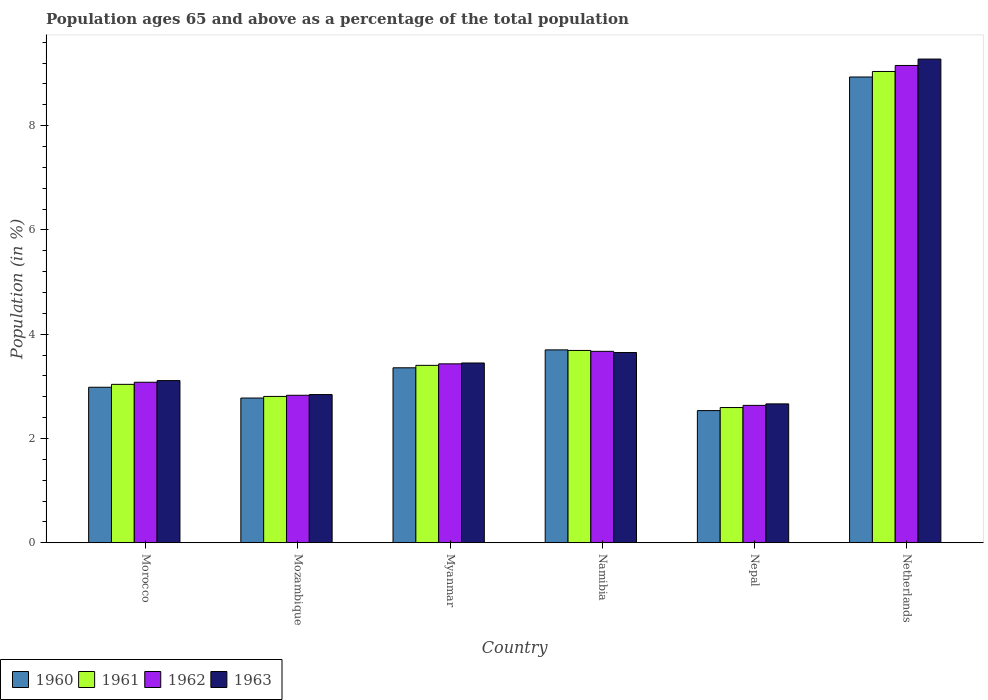How many groups of bars are there?
Give a very brief answer. 6. Are the number of bars on each tick of the X-axis equal?
Give a very brief answer. Yes. What is the label of the 3rd group of bars from the left?
Offer a very short reply. Myanmar. What is the percentage of the population ages 65 and above in 1960 in Nepal?
Offer a very short reply. 2.53. Across all countries, what is the maximum percentage of the population ages 65 and above in 1962?
Provide a short and direct response. 9.15. Across all countries, what is the minimum percentage of the population ages 65 and above in 1960?
Your answer should be very brief. 2.53. In which country was the percentage of the population ages 65 and above in 1963 minimum?
Keep it short and to the point. Nepal. What is the total percentage of the population ages 65 and above in 1960 in the graph?
Provide a short and direct response. 24.28. What is the difference between the percentage of the population ages 65 and above in 1961 in Nepal and that in Netherlands?
Your answer should be compact. -6.45. What is the difference between the percentage of the population ages 65 and above in 1960 in Namibia and the percentage of the population ages 65 and above in 1961 in Mozambique?
Offer a very short reply. 0.89. What is the average percentage of the population ages 65 and above in 1960 per country?
Offer a very short reply. 4.05. What is the difference between the percentage of the population ages 65 and above of/in 1962 and percentage of the population ages 65 and above of/in 1963 in Mozambique?
Provide a short and direct response. -0.01. What is the ratio of the percentage of the population ages 65 and above in 1961 in Morocco to that in Namibia?
Provide a succinct answer. 0.82. Is the percentage of the population ages 65 and above in 1961 in Morocco less than that in Namibia?
Provide a succinct answer. Yes. What is the difference between the highest and the second highest percentage of the population ages 65 and above in 1963?
Offer a very short reply. -5.83. What is the difference between the highest and the lowest percentage of the population ages 65 and above in 1960?
Your response must be concise. 6.4. In how many countries, is the percentage of the population ages 65 and above in 1960 greater than the average percentage of the population ages 65 and above in 1960 taken over all countries?
Ensure brevity in your answer.  1. Is it the case that in every country, the sum of the percentage of the population ages 65 and above in 1961 and percentage of the population ages 65 and above in 1963 is greater than the sum of percentage of the population ages 65 and above in 1962 and percentage of the population ages 65 and above in 1960?
Offer a terse response. No. What does the 1st bar from the left in Myanmar represents?
Provide a succinct answer. 1960. Is it the case that in every country, the sum of the percentage of the population ages 65 and above in 1960 and percentage of the population ages 65 and above in 1961 is greater than the percentage of the population ages 65 and above in 1963?
Ensure brevity in your answer.  Yes. How many countries are there in the graph?
Make the answer very short. 6. What is the difference between two consecutive major ticks on the Y-axis?
Your answer should be compact. 2. Does the graph contain any zero values?
Give a very brief answer. No. How are the legend labels stacked?
Ensure brevity in your answer.  Horizontal. What is the title of the graph?
Offer a very short reply. Population ages 65 and above as a percentage of the total population. Does "2005" appear as one of the legend labels in the graph?
Give a very brief answer. No. What is the label or title of the Y-axis?
Your answer should be compact. Population (in %). What is the Population (in %) in 1960 in Morocco?
Your response must be concise. 2.98. What is the Population (in %) of 1961 in Morocco?
Your response must be concise. 3.04. What is the Population (in %) of 1962 in Morocco?
Ensure brevity in your answer.  3.08. What is the Population (in %) of 1963 in Morocco?
Your answer should be very brief. 3.11. What is the Population (in %) in 1960 in Mozambique?
Offer a very short reply. 2.78. What is the Population (in %) in 1961 in Mozambique?
Provide a succinct answer. 2.81. What is the Population (in %) of 1962 in Mozambique?
Your answer should be very brief. 2.83. What is the Population (in %) of 1963 in Mozambique?
Keep it short and to the point. 2.84. What is the Population (in %) in 1960 in Myanmar?
Give a very brief answer. 3.36. What is the Population (in %) of 1961 in Myanmar?
Your answer should be compact. 3.4. What is the Population (in %) in 1962 in Myanmar?
Provide a short and direct response. 3.43. What is the Population (in %) of 1963 in Myanmar?
Make the answer very short. 3.45. What is the Population (in %) of 1960 in Namibia?
Provide a short and direct response. 3.7. What is the Population (in %) of 1961 in Namibia?
Offer a very short reply. 3.69. What is the Population (in %) of 1962 in Namibia?
Your response must be concise. 3.67. What is the Population (in %) of 1963 in Namibia?
Offer a very short reply. 3.65. What is the Population (in %) in 1960 in Nepal?
Give a very brief answer. 2.53. What is the Population (in %) of 1961 in Nepal?
Give a very brief answer. 2.59. What is the Population (in %) in 1962 in Nepal?
Your answer should be compact. 2.63. What is the Population (in %) of 1963 in Nepal?
Provide a succinct answer. 2.66. What is the Population (in %) of 1960 in Netherlands?
Your answer should be compact. 8.93. What is the Population (in %) in 1961 in Netherlands?
Provide a succinct answer. 9.04. What is the Population (in %) of 1962 in Netherlands?
Provide a succinct answer. 9.15. What is the Population (in %) of 1963 in Netherlands?
Your answer should be very brief. 9.28. Across all countries, what is the maximum Population (in %) of 1960?
Your answer should be compact. 8.93. Across all countries, what is the maximum Population (in %) in 1961?
Your response must be concise. 9.04. Across all countries, what is the maximum Population (in %) of 1962?
Provide a succinct answer. 9.15. Across all countries, what is the maximum Population (in %) of 1963?
Offer a very short reply. 9.28. Across all countries, what is the minimum Population (in %) in 1960?
Make the answer very short. 2.53. Across all countries, what is the minimum Population (in %) in 1961?
Your answer should be compact. 2.59. Across all countries, what is the minimum Population (in %) in 1962?
Ensure brevity in your answer.  2.63. Across all countries, what is the minimum Population (in %) of 1963?
Give a very brief answer. 2.66. What is the total Population (in %) in 1960 in the graph?
Provide a succinct answer. 24.28. What is the total Population (in %) of 1961 in the graph?
Your response must be concise. 24.57. What is the total Population (in %) of 1962 in the graph?
Give a very brief answer. 24.8. What is the total Population (in %) of 1963 in the graph?
Your answer should be compact. 24.99. What is the difference between the Population (in %) of 1960 in Morocco and that in Mozambique?
Make the answer very short. 0.21. What is the difference between the Population (in %) in 1961 in Morocco and that in Mozambique?
Your answer should be very brief. 0.23. What is the difference between the Population (in %) in 1962 in Morocco and that in Mozambique?
Give a very brief answer. 0.25. What is the difference between the Population (in %) in 1963 in Morocco and that in Mozambique?
Your response must be concise. 0.27. What is the difference between the Population (in %) of 1960 in Morocco and that in Myanmar?
Keep it short and to the point. -0.37. What is the difference between the Population (in %) of 1961 in Morocco and that in Myanmar?
Keep it short and to the point. -0.36. What is the difference between the Population (in %) in 1962 in Morocco and that in Myanmar?
Make the answer very short. -0.35. What is the difference between the Population (in %) of 1963 in Morocco and that in Myanmar?
Keep it short and to the point. -0.34. What is the difference between the Population (in %) of 1960 in Morocco and that in Namibia?
Ensure brevity in your answer.  -0.72. What is the difference between the Population (in %) in 1961 in Morocco and that in Namibia?
Your answer should be very brief. -0.65. What is the difference between the Population (in %) of 1962 in Morocco and that in Namibia?
Your answer should be compact. -0.59. What is the difference between the Population (in %) of 1963 in Morocco and that in Namibia?
Offer a very short reply. -0.54. What is the difference between the Population (in %) of 1960 in Morocco and that in Nepal?
Offer a very short reply. 0.45. What is the difference between the Population (in %) in 1961 in Morocco and that in Nepal?
Offer a terse response. 0.44. What is the difference between the Population (in %) in 1962 in Morocco and that in Nepal?
Ensure brevity in your answer.  0.44. What is the difference between the Population (in %) in 1963 in Morocco and that in Nepal?
Give a very brief answer. 0.45. What is the difference between the Population (in %) in 1960 in Morocco and that in Netherlands?
Ensure brevity in your answer.  -5.95. What is the difference between the Population (in %) in 1961 in Morocco and that in Netherlands?
Provide a short and direct response. -6. What is the difference between the Population (in %) in 1962 in Morocco and that in Netherlands?
Your answer should be compact. -6.08. What is the difference between the Population (in %) in 1963 in Morocco and that in Netherlands?
Keep it short and to the point. -6.17. What is the difference between the Population (in %) in 1960 in Mozambique and that in Myanmar?
Ensure brevity in your answer.  -0.58. What is the difference between the Population (in %) in 1961 in Mozambique and that in Myanmar?
Make the answer very short. -0.6. What is the difference between the Population (in %) of 1962 in Mozambique and that in Myanmar?
Ensure brevity in your answer.  -0.6. What is the difference between the Population (in %) in 1963 in Mozambique and that in Myanmar?
Your answer should be very brief. -0.61. What is the difference between the Population (in %) in 1960 in Mozambique and that in Namibia?
Offer a very short reply. -0.92. What is the difference between the Population (in %) in 1961 in Mozambique and that in Namibia?
Give a very brief answer. -0.88. What is the difference between the Population (in %) of 1962 in Mozambique and that in Namibia?
Your answer should be very brief. -0.84. What is the difference between the Population (in %) in 1963 in Mozambique and that in Namibia?
Your answer should be compact. -0.81. What is the difference between the Population (in %) of 1960 in Mozambique and that in Nepal?
Give a very brief answer. 0.24. What is the difference between the Population (in %) of 1961 in Mozambique and that in Nepal?
Offer a terse response. 0.21. What is the difference between the Population (in %) of 1962 in Mozambique and that in Nepal?
Give a very brief answer. 0.19. What is the difference between the Population (in %) in 1963 in Mozambique and that in Nepal?
Offer a terse response. 0.18. What is the difference between the Population (in %) in 1960 in Mozambique and that in Netherlands?
Your answer should be very brief. -6.16. What is the difference between the Population (in %) of 1961 in Mozambique and that in Netherlands?
Give a very brief answer. -6.23. What is the difference between the Population (in %) of 1962 in Mozambique and that in Netherlands?
Provide a succinct answer. -6.33. What is the difference between the Population (in %) in 1963 in Mozambique and that in Netherlands?
Provide a succinct answer. -6.44. What is the difference between the Population (in %) of 1960 in Myanmar and that in Namibia?
Your answer should be very brief. -0.34. What is the difference between the Population (in %) of 1961 in Myanmar and that in Namibia?
Make the answer very short. -0.29. What is the difference between the Population (in %) of 1962 in Myanmar and that in Namibia?
Offer a terse response. -0.24. What is the difference between the Population (in %) of 1963 in Myanmar and that in Namibia?
Give a very brief answer. -0.2. What is the difference between the Population (in %) in 1960 in Myanmar and that in Nepal?
Offer a terse response. 0.82. What is the difference between the Population (in %) of 1961 in Myanmar and that in Nepal?
Ensure brevity in your answer.  0.81. What is the difference between the Population (in %) of 1962 in Myanmar and that in Nepal?
Offer a terse response. 0.8. What is the difference between the Population (in %) in 1963 in Myanmar and that in Nepal?
Give a very brief answer. 0.78. What is the difference between the Population (in %) of 1960 in Myanmar and that in Netherlands?
Ensure brevity in your answer.  -5.58. What is the difference between the Population (in %) of 1961 in Myanmar and that in Netherlands?
Offer a very short reply. -5.64. What is the difference between the Population (in %) of 1962 in Myanmar and that in Netherlands?
Offer a very short reply. -5.72. What is the difference between the Population (in %) of 1963 in Myanmar and that in Netherlands?
Provide a short and direct response. -5.83. What is the difference between the Population (in %) in 1960 in Namibia and that in Nepal?
Your answer should be compact. 1.16. What is the difference between the Population (in %) of 1961 in Namibia and that in Nepal?
Provide a succinct answer. 1.1. What is the difference between the Population (in %) of 1962 in Namibia and that in Nepal?
Your answer should be very brief. 1.04. What is the difference between the Population (in %) of 1963 in Namibia and that in Nepal?
Offer a very short reply. 0.99. What is the difference between the Population (in %) of 1960 in Namibia and that in Netherlands?
Offer a terse response. -5.23. What is the difference between the Population (in %) in 1961 in Namibia and that in Netherlands?
Your answer should be compact. -5.35. What is the difference between the Population (in %) in 1962 in Namibia and that in Netherlands?
Provide a short and direct response. -5.48. What is the difference between the Population (in %) in 1963 in Namibia and that in Netherlands?
Give a very brief answer. -5.63. What is the difference between the Population (in %) of 1960 in Nepal and that in Netherlands?
Provide a succinct answer. -6.4. What is the difference between the Population (in %) in 1961 in Nepal and that in Netherlands?
Make the answer very short. -6.45. What is the difference between the Population (in %) of 1962 in Nepal and that in Netherlands?
Ensure brevity in your answer.  -6.52. What is the difference between the Population (in %) of 1963 in Nepal and that in Netherlands?
Your answer should be compact. -6.61. What is the difference between the Population (in %) of 1960 in Morocco and the Population (in %) of 1961 in Mozambique?
Keep it short and to the point. 0.18. What is the difference between the Population (in %) in 1960 in Morocco and the Population (in %) in 1962 in Mozambique?
Provide a succinct answer. 0.15. What is the difference between the Population (in %) in 1960 in Morocco and the Population (in %) in 1963 in Mozambique?
Keep it short and to the point. 0.14. What is the difference between the Population (in %) in 1961 in Morocco and the Population (in %) in 1962 in Mozambique?
Give a very brief answer. 0.21. What is the difference between the Population (in %) of 1961 in Morocco and the Population (in %) of 1963 in Mozambique?
Your answer should be compact. 0.2. What is the difference between the Population (in %) of 1962 in Morocco and the Population (in %) of 1963 in Mozambique?
Your answer should be compact. 0.24. What is the difference between the Population (in %) of 1960 in Morocco and the Population (in %) of 1961 in Myanmar?
Make the answer very short. -0.42. What is the difference between the Population (in %) in 1960 in Morocco and the Population (in %) in 1962 in Myanmar?
Provide a succinct answer. -0.45. What is the difference between the Population (in %) in 1960 in Morocco and the Population (in %) in 1963 in Myanmar?
Make the answer very short. -0.47. What is the difference between the Population (in %) in 1961 in Morocco and the Population (in %) in 1962 in Myanmar?
Give a very brief answer. -0.39. What is the difference between the Population (in %) of 1961 in Morocco and the Population (in %) of 1963 in Myanmar?
Offer a terse response. -0.41. What is the difference between the Population (in %) of 1962 in Morocco and the Population (in %) of 1963 in Myanmar?
Make the answer very short. -0.37. What is the difference between the Population (in %) in 1960 in Morocco and the Population (in %) in 1961 in Namibia?
Offer a very short reply. -0.71. What is the difference between the Population (in %) of 1960 in Morocco and the Population (in %) of 1962 in Namibia?
Keep it short and to the point. -0.69. What is the difference between the Population (in %) in 1960 in Morocco and the Population (in %) in 1963 in Namibia?
Your response must be concise. -0.67. What is the difference between the Population (in %) in 1961 in Morocco and the Population (in %) in 1962 in Namibia?
Your response must be concise. -0.63. What is the difference between the Population (in %) of 1961 in Morocco and the Population (in %) of 1963 in Namibia?
Keep it short and to the point. -0.61. What is the difference between the Population (in %) in 1962 in Morocco and the Population (in %) in 1963 in Namibia?
Give a very brief answer. -0.57. What is the difference between the Population (in %) of 1960 in Morocco and the Population (in %) of 1961 in Nepal?
Give a very brief answer. 0.39. What is the difference between the Population (in %) of 1960 in Morocco and the Population (in %) of 1962 in Nepal?
Your answer should be very brief. 0.35. What is the difference between the Population (in %) in 1960 in Morocco and the Population (in %) in 1963 in Nepal?
Give a very brief answer. 0.32. What is the difference between the Population (in %) in 1961 in Morocco and the Population (in %) in 1962 in Nepal?
Give a very brief answer. 0.4. What is the difference between the Population (in %) in 1961 in Morocco and the Population (in %) in 1963 in Nepal?
Give a very brief answer. 0.37. What is the difference between the Population (in %) in 1962 in Morocco and the Population (in %) in 1963 in Nepal?
Make the answer very short. 0.41. What is the difference between the Population (in %) of 1960 in Morocco and the Population (in %) of 1961 in Netherlands?
Offer a terse response. -6.06. What is the difference between the Population (in %) in 1960 in Morocco and the Population (in %) in 1962 in Netherlands?
Offer a terse response. -6.17. What is the difference between the Population (in %) in 1960 in Morocco and the Population (in %) in 1963 in Netherlands?
Provide a short and direct response. -6.3. What is the difference between the Population (in %) in 1961 in Morocco and the Population (in %) in 1962 in Netherlands?
Make the answer very short. -6.12. What is the difference between the Population (in %) in 1961 in Morocco and the Population (in %) in 1963 in Netherlands?
Your answer should be compact. -6.24. What is the difference between the Population (in %) in 1962 in Morocco and the Population (in %) in 1963 in Netherlands?
Offer a very short reply. -6.2. What is the difference between the Population (in %) in 1960 in Mozambique and the Population (in %) in 1961 in Myanmar?
Keep it short and to the point. -0.63. What is the difference between the Population (in %) in 1960 in Mozambique and the Population (in %) in 1962 in Myanmar?
Ensure brevity in your answer.  -0.66. What is the difference between the Population (in %) of 1960 in Mozambique and the Population (in %) of 1963 in Myanmar?
Provide a succinct answer. -0.67. What is the difference between the Population (in %) in 1961 in Mozambique and the Population (in %) in 1962 in Myanmar?
Your answer should be compact. -0.62. What is the difference between the Population (in %) of 1961 in Mozambique and the Population (in %) of 1963 in Myanmar?
Offer a very short reply. -0.64. What is the difference between the Population (in %) in 1962 in Mozambique and the Population (in %) in 1963 in Myanmar?
Your answer should be compact. -0.62. What is the difference between the Population (in %) of 1960 in Mozambique and the Population (in %) of 1961 in Namibia?
Your answer should be compact. -0.91. What is the difference between the Population (in %) in 1960 in Mozambique and the Population (in %) in 1962 in Namibia?
Keep it short and to the point. -0.9. What is the difference between the Population (in %) of 1960 in Mozambique and the Population (in %) of 1963 in Namibia?
Offer a very short reply. -0.87. What is the difference between the Population (in %) in 1961 in Mozambique and the Population (in %) in 1962 in Namibia?
Provide a short and direct response. -0.86. What is the difference between the Population (in %) of 1961 in Mozambique and the Population (in %) of 1963 in Namibia?
Your response must be concise. -0.84. What is the difference between the Population (in %) of 1962 in Mozambique and the Population (in %) of 1963 in Namibia?
Offer a terse response. -0.82. What is the difference between the Population (in %) of 1960 in Mozambique and the Population (in %) of 1961 in Nepal?
Offer a terse response. 0.18. What is the difference between the Population (in %) in 1960 in Mozambique and the Population (in %) in 1962 in Nepal?
Offer a very short reply. 0.14. What is the difference between the Population (in %) of 1960 in Mozambique and the Population (in %) of 1963 in Nepal?
Offer a very short reply. 0.11. What is the difference between the Population (in %) in 1961 in Mozambique and the Population (in %) in 1962 in Nepal?
Provide a succinct answer. 0.17. What is the difference between the Population (in %) of 1961 in Mozambique and the Population (in %) of 1963 in Nepal?
Provide a short and direct response. 0.14. What is the difference between the Population (in %) of 1962 in Mozambique and the Population (in %) of 1963 in Nepal?
Give a very brief answer. 0.17. What is the difference between the Population (in %) in 1960 in Mozambique and the Population (in %) in 1961 in Netherlands?
Provide a succinct answer. -6.26. What is the difference between the Population (in %) in 1960 in Mozambique and the Population (in %) in 1962 in Netherlands?
Give a very brief answer. -6.38. What is the difference between the Population (in %) of 1960 in Mozambique and the Population (in %) of 1963 in Netherlands?
Ensure brevity in your answer.  -6.5. What is the difference between the Population (in %) in 1961 in Mozambique and the Population (in %) in 1962 in Netherlands?
Ensure brevity in your answer.  -6.35. What is the difference between the Population (in %) of 1961 in Mozambique and the Population (in %) of 1963 in Netherlands?
Provide a short and direct response. -6.47. What is the difference between the Population (in %) in 1962 in Mozambique and the Population (in %) in 1963 in Netherlands?
Your answer should be compact. -6.45. What is the difference between the Population (in %) in 1960 in Myanmar and the Population (in %) in 1961 in Namibia?
Your response must be concise. -0.33. What is the difference between the Population (in %) of 1960 in Myanmar and the Population (in %) of 1962 in Namibia?
Provide a short and direct response. -0.32. What is the difference between the Population (in %) of 1960 in Myanmar and the Population (in %) of 1963 in Namibia?
Your answer should be compact. -0.29. What is the difference between the Population (in %) in 1961 in Myanmar and the Population (in %) in 1962 in Namibia?
Provide a short and direct response. -0.27. What is the difference between the Population (in %) in 1961 in Myanmar and the Population (in %) in 1963 in Namibia?
Offer a very short reply. -0.25. What is the difference between the Population (in %) in 1962 in Myanmar and the Population (in %) in 1963 in Namibia?
Ensure brevity in your answer.  -0.22. What is the difference between the Population (in %) in 1960 in Myanmar and the Population (in %) in 1961 in Nepal?
Give a very brief answer. 0.76. What is the difference between the Population (in %) of 1960 in Myanmar and the Population (in %) of 1962 in Nepal?
Keep it short and to the point. 0.72. What is the difference between the Population (in %) of 1960 in Myanmar and the Population (in %) of 1963 in Nepal?
Your answer should be compact. 0.69. What is the difference between the Population (in %) in 1961 in Myanmar and the Population (in %) in 1962 in Nepal?
Give a very brief answer. 0.77. What is the difference between the Population (in %) in 1961 in Myanmar and the Population (in %) in 1963 in Nepal?
Provide a succinct answer. 0.74. What is the difference between the Population (in %) in 1962 in Myanmar and the Population (in %) in 1963 in Nepal?
Keep it short and to the point. 0.77. What is the difference between the Population (in %) of 1960 in Myanmar and the Population (in %) of 1961 in Netherlands?
Give a very brief answer. -5.68. What is the difference between the Population (in %) of 1960 in Myanmar and the Population (in %) of 1962 in Netherlands?
Ensure brevity in your answer.  -5.8. What is the difference between the Population (in %) in 1960 in Myanmar and the Population (in %) in 1963 in Netherlands?
Provide a succinct answer. -5.92. What is the difference between the Population (in %) in 1961 in Myanmar and the Population (in %) in 1962 in Netherlands?
Give a very brief answer. -5.75. What is the difference between the Population (in %) of 1961 in Myanmar and the Population (in %) of 1963 in Netherlands?
Offer a terse response. -5.88. What is the difference between the Population (in %) of 1962 in Myanmar and the Population (in %) of 1963 in Netherlands?
Your answer should be compact. -5.85. What is the difference between the Population (in %) of 1960 in Namibia and the Population (in %) of 1961 in Nepal?
Your answer should be very brief. 1.11. What is the difference between the Population (in %) in 1960 in Namibia and the Population (in %) in 1962 in Nepal?
Provide a short and direct response. 1.06. What is the difference between the Population (in %) of 1960 in Namibia and the Population (in %) of 1963 in Nepal?
Your answer should be compact. 1.04. What is the difference between the Population (in %) of 1961 in Namibia and the Population (in %) of 1962 in Nepal?
Give a very brief answer. 1.05. What is the difference between the Population (in %) in 1961 in Namibia and the Population (in %) in 1963 in Nepal?
Give a very brief answer. 1.03. What is the difference between the Population (in %) in 1962 in Namibia and the Population (in %) in 1963 in Nepal?
Your response must be concise. 1.01. What is the difference between the Population (in %) of 1960 in Namibia and the Population (in %) of 1961 in Netherlands?
Ensure brevity in your answer.  -5.34. What is the difference between the Population (in %) of 1960 in Namibia and the Population (in %) of 1962 in Netherlands?
Keep it short and to the point. -5.46. What is the difference between the Population (in %) of 1960 in Namibia and the Population (in %) of 1963 in Netherlands?
Your answer should be compact. -5.58. What is the difference between the Population (in %) in 1961 in Namibia and the Population (in %) in 1962 in Netherlands?
Give a very brief answer. -5.47. What is the difference between the Population (in %) in 1961 in Namibia and the Population (in %) in 1963 in Netherlands?
Provide a succinct answer. -5.59. What is the difference between the Population (in %) of 1962 in Namibia and the Population (in %) of 1963 in Netherlands?
Your answer should be very brief. -5.61. What is the difference between the Population (in %) in 1960 in Nepal and the Population (in %) in 1961 in Netherlands?
Ensure brevity in your answer.  -6.5. What is the difference between the Population (in %) of 1960 in Nepal and the Population (in %) of 1962 in Netherlands?
Make the answer very short. -6.62. What is the difference between the Population (in %) of 1960 in Nepal and the Population (in %) of 1963 in Netherlands?
Provide a short and direct response. -6.74. What is the difference between the Population (in %) in 1961 in Nepal and the Population (in %) in 1962 in Netherlands?
Your answer should be compact. -6.56. What is the difference between the Population (in %) in 1961 in Nepal and the Population (in %) in 1963 in Netherlands?
Your answer should be compact. -6.68. What is the difference between the Population (in %) of 1962 in Nepal and the Population (in %) of 1963 in Netherlands?
Your answer should be compact. -6.64. What is the average Population (in %) of 1960 per country?
Provide a short and direct response. 4.05. What is the average Population (in %) of 1961 per country?
Ensure brevity in your answer.  4.09. What is the average Population (in %) in 1962 per country?
Your answer should be compact. 4.13. What is the average Population (in %) in 1963 per country?
Provide a succinct answer. 4.16. What is the difference between the Population (in %) of 1960 and Population (in %) of 1961 in Morocco?
Your answer should be compact. -0.06. What is the difference between the Population (in %) in 1960 and Population (in %) in 1962 in Morocco?
Make the answer very short. -0.1. What is the difference between the Population (in %) in 1960 and Population (in %) in 1963 in Morocco?
Offer a very short reply. -0.13. What is the difference between the Population (in %) of 1961 and Population (in %) of 1962 in Morocco?
Offer a very short reply. -0.04. What is the difference between the Population (in %) in 1961 and Population (in %) in 1963 in Morocco?
Give a very brief answer. -0.07. What is the difference between the Population (in %) in 1962 and Population (in %) in 1963 in Morocco?
Ensure brevity in your answer.  -0.03. What is the difference between the Population (in %) of 1960 and Population (in %) of 1961 in Mozambique?
Provide a succinct answer. -0.03. What is the difference between the Population (in %) in 1960 and Population (in %) in 1962 in Mozambique?
Offer a very short reply. -0.05. What is the difference between the Population (in %) of 1960 and Population (in %) of 1963 in Mozambique?
Your answer should be compact. -0.07. What is the difference between the Population (in %) of 1961 and Population (in %) of 1962 in Mozambique?
Offer a terse response. -0.02. What is the difference between the Population (in %) in 1961 and Population (in %) in 1963 in Mozambique?
Offer a very short reply. -0.04. What is the difference between the Population (in %) of 1962 and Population (in %) of 1963 in Mozambique?
Keep it short and to the point. -0.01. What is the difference between the Population (in %) in 1960 and Population (in %) in 1961 in Myanmar?
Your answer should be very brief. -0.05. What is the difference between the Population (in %) of 1960 and Population (in %) of 1962 in Myanmar?
Give a very brief answer. -0.08. What is the difference between the Population (in %) of 1960 and Population (in %) of 1963 in Myanmar?
Keep it short and to the point. -0.09. What is the difference between the Population (in %) in 1961 and Population (in %) in 1962 in Myanmar?
Your response must be concise. -0.03. What is the difference between the Population (in %) in 1961 and Population (in %) in 1963 in Myanmar?
Provide a short and direct response. -0.04. What is the difference between the Population (in %) in 1962 and Population (in %) in 1963 in Myanmar?
Provide a short and direct response. -0.02. What is the difference between the Population (in %) in 1960 and Population (in %) in 1961 in Namibia?
Offer a very short reply. 0.01. What is the difference between the Population (in %) of 1960 and Population (in %) of 1962 in Namibia?
Offer a terse response. 0.03. What is the difference between the Population (in %) of 1960 and Population (in %) of 1963 in Namibia?
Make the answer very short. 0.05. What is the difference between the Population (in %) in 1961 and Population (in %) in 1962 in Namibia?
Give a very brief answer. 0.02. What is the difference between the Population (in %) of 1961 and Population (in %) of 1963 in Namibia?
Ensure brevity in your answer.  0.04. What is the difference between the Population (in %) in 1962 and Population (in %) in 1963 in Namibia?
Make the answer very short. 0.02. What is the difference between the Population (in %) of 1960 and Population (in %) of 1961 in Nepal?
Your answer should be very brief. -0.06. What is the difference between the Population (in %) in 1960 and Population (in %) in 1962 in Nepal?
Ensure brevity in your answer.  -0.1. What is the difference between the Population (in %) in 1960 and Population (in %) in 1963 in Nepal?
Make the answer very short. -0.13. What is the difference between the Population (in %) of 1961 and Population (in %) of 1962 in Nepal?
Provide a succinct answer. -0.04. What is the difference between the Population (in %) in 1961 and Population (in %) in 1963 in Nepal?
Provide a succinct answer. -0.07. What is the difference between the Population (in %) of 1962 and Population (in %) of 1963 in Nepal?
Provide a succinct answer. -0.03. What is the difference between the Population (in %) in 1960 and Population (in %) in 1961 in Netherlands?
Your answer should be compact. -0.11. What is the difference between the Population (in %) in 1960 and Population (in %) in 1962 in Netherlands?
Keep it short and to the point. -0.22. What is the difference between the Population (in %) of 1960 and Population (in %) of 1963 in Netherlands?
Make the answer very short. -0.34. What is the difference between the Population (in %) of 1961 and Population (in %) of 1962 in Netherlands?
Offer a terse response. -0.12. What is the difference between the Population (in %) in 1961 and Population (in %) in 1963 in Netherlands?
Ensure brevity in your answer.  -0.24. What is the difference between the Population (in %) in 1962 and Population (in %) in 1963 in Netherlands?
Your answer should be very brief. -0.12. What is the ratio of the Population (in %) of 1960 in Morocco to that in Mozambique?
Give a very brief answer. 1.07. What is the ratio of the Population (in %) in 1961 in Morocco to that in Mozambique?
Keep it short and to the point. 1.08. What is the ratio of the Population (in %) of 1962 in Morocco to that in Mozambique?
Your response must be concise. 1.09. What is the ratio of the Population (in %) of 1963 in Morocco to that in Mozambique?
Your response must be concise. 1.09. What is the ratio of the Population (in %) of 1960 in Morocco to that in Myanmar?
Offer a very short reply. 0.89. What is the ratio of the Population (in %) in 1961 in Morocco to that in Myanmar?
Ensure brevity in your answer.  0.89. What is the ratio of the Population (in %) in 1962 in Morocco to that in Myanmar?
Provide a short and direct response. 0.9. What is the ratio of the Population (in %) in 1963 in Morocco to that in Myanmar?
Ensure brevity in your answer.  0.9. What is the ratio of the Population (in %) of 1960 in Morocco to that in Namibia?
Your answer should be compact. 0.81. What is the ratio of the Population (in %) in 1961 in Morocco to that in Namibia?
Your response must be concise. 0.82. What is the ratio of the Population (in %) in 1962 in Morocco to that in Namibia?
Your answer should be very brief. 0.84. What is the ratio of the Population (in %) in 1963 in Morocco to that in Namibia?
Offer a very short reply. 0.85. What is the ratio of the Population (in %) in 1960 in Morocco to that in Nepal?
Provide a succinct answer. 1.18. What is the ratio of the Population (in %) of 1961 in Morocco to that in Nepal?
Provide a succinct answer. 1.17. What is the ratio of the Population (in %) in 1962 in Morocco to that in Nepal?
Your answer should be very brief. 1.17. What is the ratio of the Population (in %) of 1963 in Morocco to that in Nepal?
Provide a succinct answer. 1.17. What is the ratio of the Population (in %) in 1960 in Morocco to that in Netherlands?
Offer a terse response. 0.33. What is the ratio of the Population (in %) in 1961 in Morocco to that in Netherlands?
Your answer should be very brief. 0.34. What is the ratio of the Population (in %) in 1962 in Morocco to that in Netherlands?
Provide a succinct answer. 0.34. What is the ratio of the Population (in %) in 1963 in Morocco to that in Netherlands?
Provide a short and direct response. 0.34. What is the ratio of the Population (in %) of 1960 in Mozambique to that in Myanmar?
Provide a short and direct response. 0.83. What is the ratio of the Population (in %) in 1961 in Mozambique to that in Myanmar?
Offer a terse response. 0.82. What is the ratio of the Population (in %) of 1962 in Mozambique to that in Myanmar?
Offer a terse response. 0.82. What is the ratio of the Population (in %) of 1963 in Mozambique to that in Myanmar?
Your answer should be very brief. 0.82. What is the ratio of the Population (in %) in 1960 in Mozambique to that in Namibia?
Provide a short and direct response. 0.75. What is the ratio of the Population (in %) in 1961 in Mozambique to that in Namibia?
Give a very brief answer. 0.76. What is the ratio of the Population (in %) of 1962 in Mozambique to that in Namibia?
Your answer should be compact. 0.77. What is the ratio of the Population (in %) of 1963 in Mozambique to that in Namibia?
Make the answer very short. 0.78. What is the ratio of the Population (in %) of 1960 in Mozambique to that in Nepal?
Your response must be concise. 1.1. What is the ratio of the Population (in %) of 1961 in Mozambique to that in Nepal?
Your answer should be very brief. 1.08. What is the ratio of the Population (in %) in 1962 in Mozambique to that in Nepal?
Make the answer very short. 1.07. What is the ratio of the Population (in %) of 1963 in Mozambique to that in Nepal?
Ensure brevity in your answer.  1.07. What is the ratio of the Population (in %) of 1960 in Mozambique to that in Netherlands?
Your answer should be very brief. 0.31. What is the ratio of the Population (in %) in 1961 in Mozambique to that in Netherlands?
Make the answer very short. 0.31. What is the ratio of the Population (in %) in 1962 in Mozambique to that in Netherlands?
Keep it short and to the point. 0.31. What is the ratio of the Population (in %) of 1963 in Mozambique to that in Netherlands?
Your response must be concise. 0.31. What is the ratio of the Population (in %) of 1960 in Myanmar to that in Namibia?
Give a very brief answer. 0.91. What is the ratio of the Population (in %) of 1961 in Myanmar to that in Namibia?
Give a very brief answer. 0.92. What is the ratio of the Population (in %) in 1962 in Myanmar to that in Namibia?
Your answer should be very brief. 0.93. What is the ratio of the Population (in %) of 1963 in Myanmar to that in Namibia?
Provide a short and direct response. 0.94. What is the ratio of the Population (in %) of 1960 in Myanmar to that in Nepal?
Offer a terse response. 1.32. What is the ratio of the Population (in %) of 1961 in Myanmar to that in Nepal?
Keep it short and to the point. 1.31. What is the ratio of the Population (in %) of 1962 in Myanmar to that in Nepal?
Offer a terse response. 1.3. What is the ratio of the Population (in %) of 1963 in Myanmar to that in Nepal?
Your response must be concise. 1.29. What is the ratio of the Population (in %) of 1960 in Myanmar to that in Netherlands?
Keep it short and to the point. 0.38. What is the ratio of the Population (in %) of 1961 in Myanmar to that in Netherlands?
Your response must be concise. 0.38. What is the ratio of the Population (in %) in 1962 in Myanmar to that in Netherlands?
Your answer should be very brief. 0.37. What is the ratio of the Population (in %) of 1963 in Myanmar to that in Netherlands?
Give a very brief answer. 0.37. What is the ratio of the Population (in %) in 1960 in Namibia to that in Nepal?
Ensure brevity in your answer.  1.46. What is the ratio of the Population (in %) in 1961 in Namibia to that in Nepal?
Your answer should be compact. 1.42. What is the ratio of the Population (in %) in 1962 in Namibia to that in Nepal?
Provide a short and direct response. 1.39. What is the ratio of the Population (in %) in 1963 in Namibia to that in Nepal?
Your answer should be very brief. 1.37. What is the ratio of the Population (in %) in 1960 in Namibia to that in Netherlands?
Provide a short and direct response. 0.41. What is the ratio of the Population (in %) of 1961 in Namibia to that in Netherlands?
Your answer should be compact. 0.41. What is the ratio of the Population (in %) of 1962 in Namibia to that in Netherlands?
Provide a short and direct response. 0.4. What is the ratio of the Population (in %) of 1963 in Namibia to that in Netherlands?
Your answer should be very brief. 0.39. What is the ratio of the Population (in %) of 1960 in Nepal to that in Netherlands?
Make the answer very short. 0.28. What is the ratio of the Population (in %) of 1961 in Nepal to that in Netherlands?
Ensure brevity in your answer.  0.29. What is the ratio of the Population (in %) in 1962 in Nepal to that in Netherlands?
Your answer should be very brief. 0.29. What is the ratio of the Population (in %) of 1963 in Nepal to that in Netherlands?
Make the answer very short. 0.29. What is the difference between the highest and the second highest Population (in %) of 1960?
Your answer should be compact. 5.23. What is the difference between the highest and the second highest Population (in %) of 1961?
Ensure brevity in your answer.  5.35. What is the difference between the highest and the second highest Population (in %) of 1962?
Offer a very short reply. 5.48. What is the difference between the highest and the second highest Population (in %) of 1963?
Provide a succinct answer. 5.63. What is the difference between the highest and the lowest Population (in %) in 1960?
Your answer should be very brief. 6.4. What is the difference between the highest and the lowest Population (in %) in 1961?
Your answer should be very brief. 6.45. What is the difference between the highest and the lowest Population (in %) of 1962?
Give a very brief answer. 6.52. What is the difference between the highest and the lowest Population (in %) of 1963?
Make the answer very short. 6.61. 